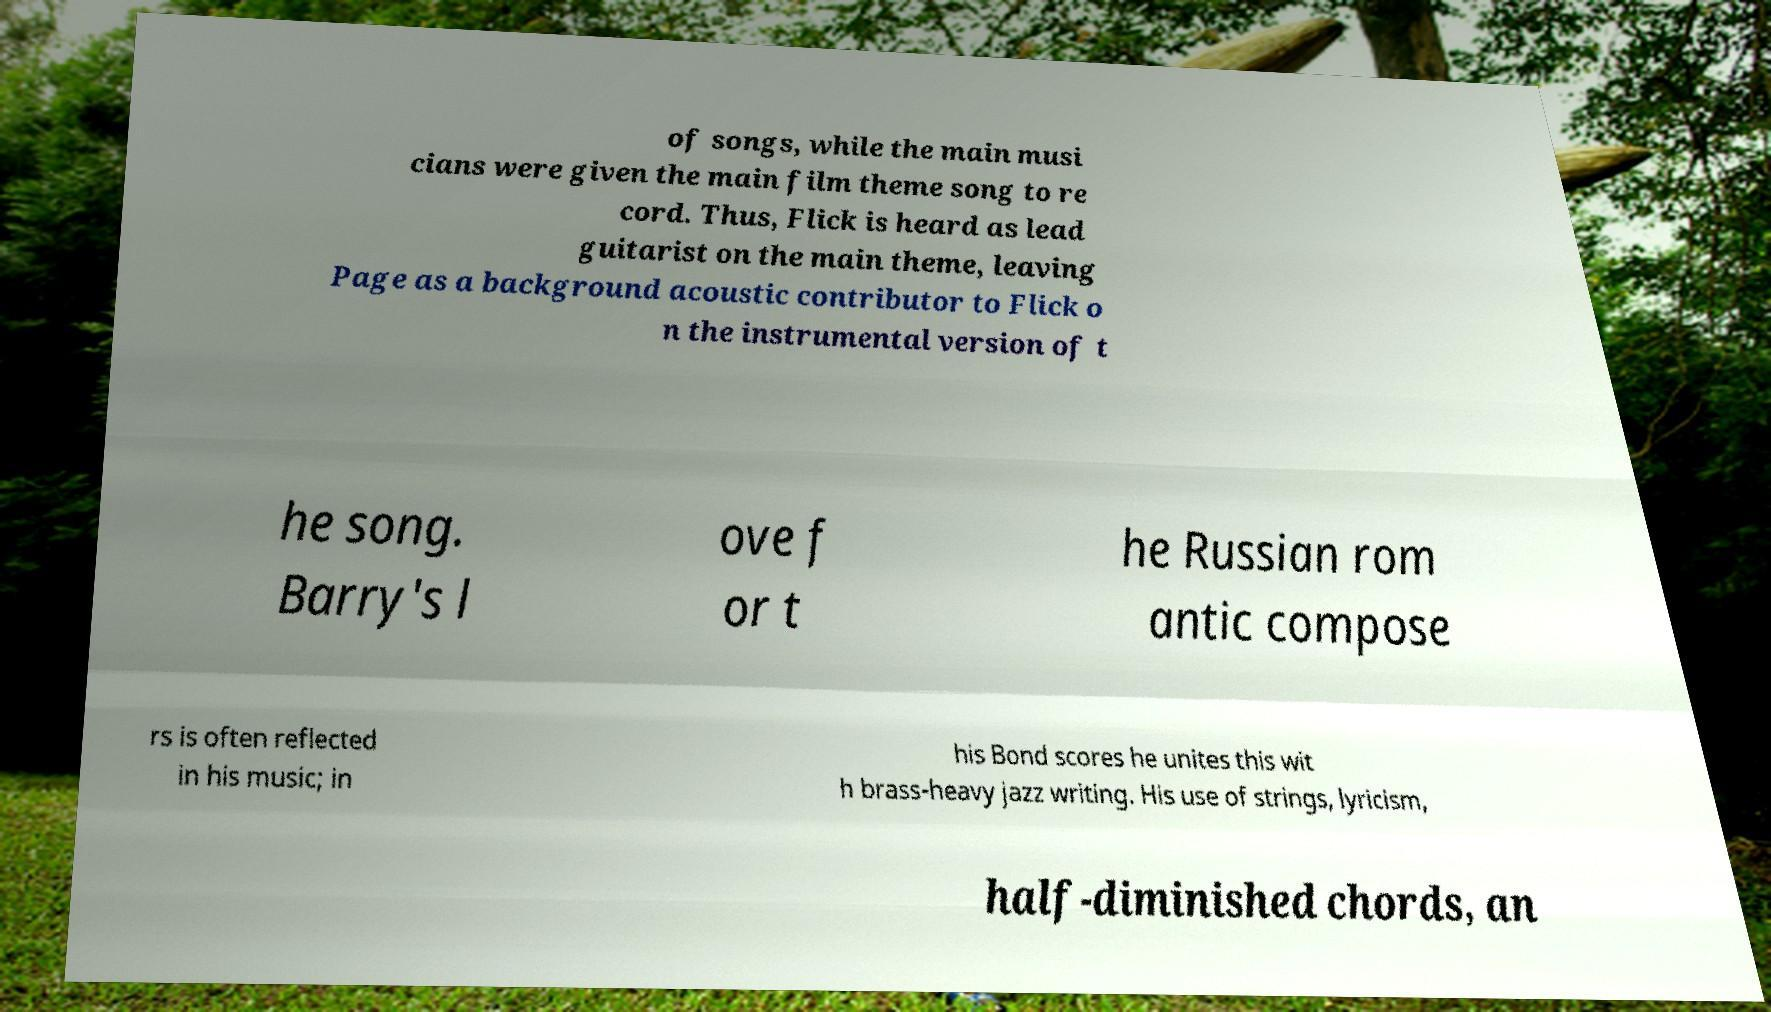Could you assist in decoding the text presented in this image and type it out clearly? of songs, while the main musi cians were given the main film theme song to re cord. Thus, Flick is heard as lead guitarist on the main theme, leaving Page as a background acoustic contributor to Flick o n the instrumental version of t he song. Barry's l ove f or t he Russian rom antic compose rs is often reflected in his music; in his Bond scores he unites this wit h brass-heavy jazz writing. His use of strings, lyricism, half-diminished chords, an 